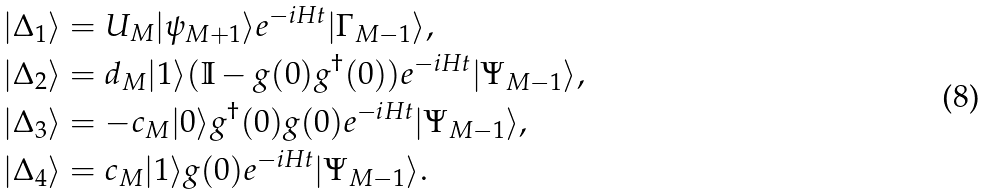<formula> <loc_0><loc_0><loc_500><loc_500>| \Delta _ { 1 } \rangle & = U _ { M } | \psi _ { M + 1 } \rangle e ^ { - i H t } | \Gamma _ { M - 1 } \rangle , \\ | \Delta _ { 2 } \rangle & = d _ { M } | 1 \rangle ( \mathbb { I } - g ( 0 ) g ^ { \dag } ( 0 ) ) e ^ { - i H t } | \Psi _ { M - 1 } \rangle , \\ | \Delta _ { 3 } \rangle & = - c _ { M } | 0 \rangle g ^ { \dag } ( 0 ) g ( 0 ) e ^ { - i H t } | \Psi _ { M - 1 } \rangle , \\ | \Delta _ { 4 } \rangle & = c _ { M } | 1 \rangle g ( 0 ) e ^ { - i H t } | \Psi _ { M - 1 } \rangle .</formula> 